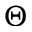<formula> <loc_0><loc_0><loc_500><loc_500>\Theta</formula> 